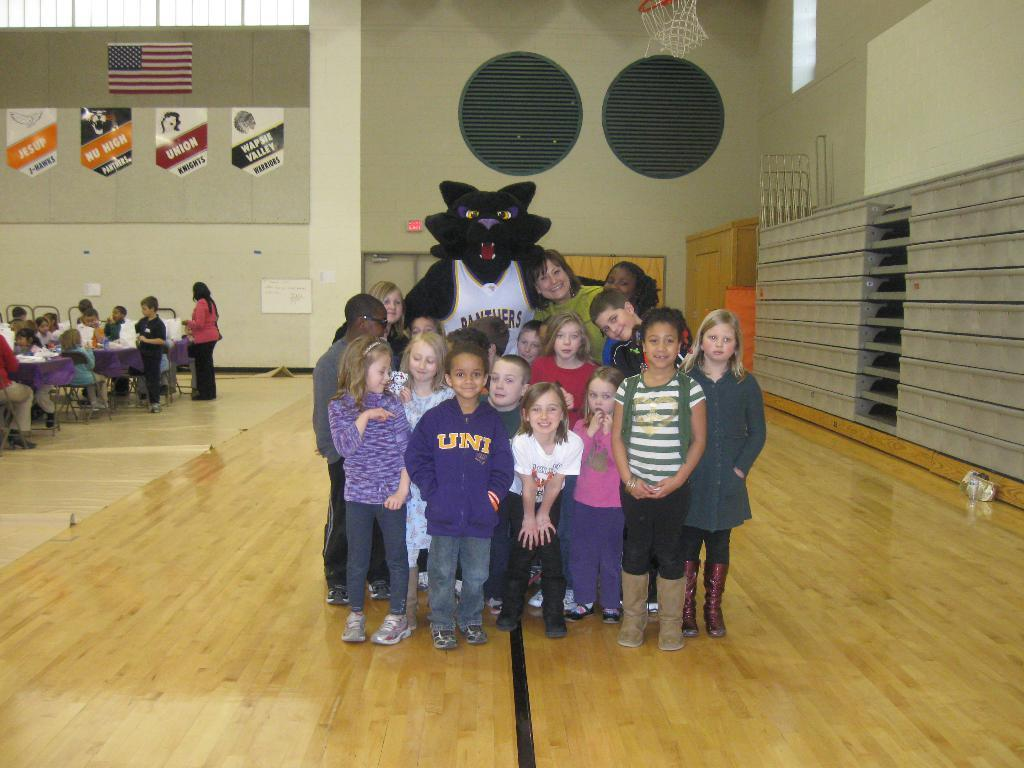Who are the main subjects in the image? There are kids and a woman in the image. What is the person wearing an animal costume doing in the image? The person wearing an animal costume is posing with the kids and the woman. Can you describe the setting of the image? There are more kids sitting on chairs near a table in the background of the image. What type of crime is being committed by the person wearing the hat in the image? There is no person wearing a hat in the image, and no crime is being committed. How does the person in the animal costume plan to attack the kids in the image? The person in the animal costume is not planning an attack; they are posing with the kids and the woman. 